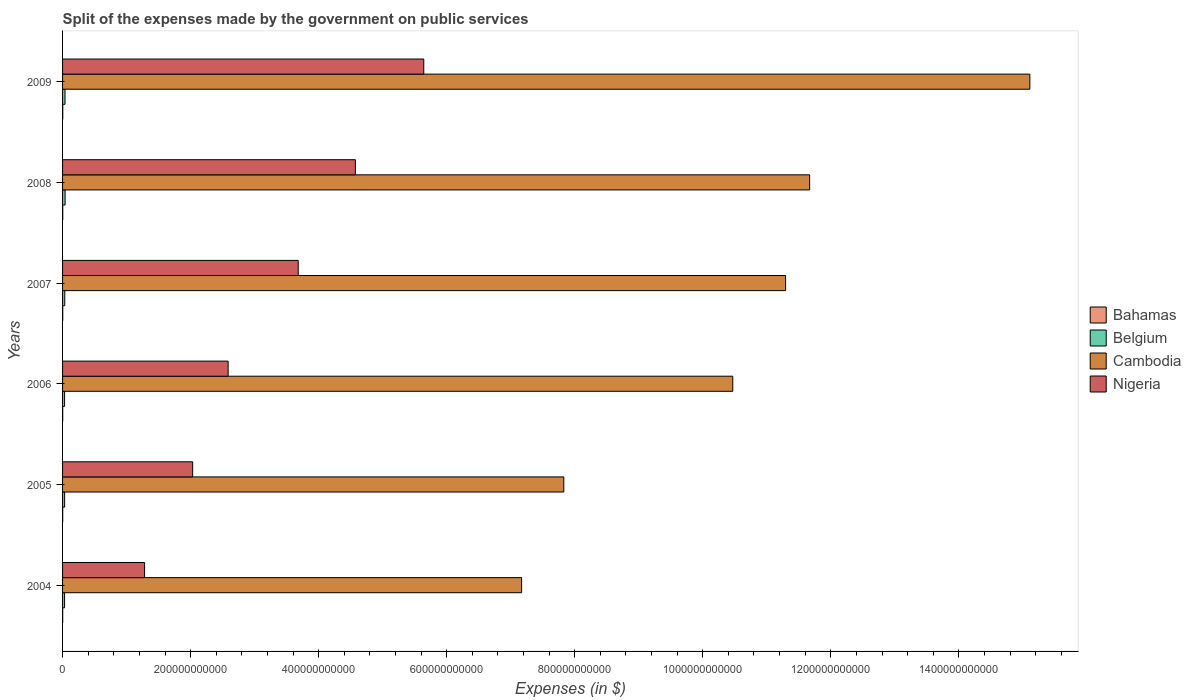Are the number of bars per tick equal to the number of legend labels?
Offer a terse response. Yes. Are the number of bars on each tick of the Y-axis equal?
Your response must be concise. Yes. What is the label of the 3rd group of bars from the top?
Give a very brief answer. 2007. In how many cases, is the number of bars for a given year not equal to the number of legend labels?
Offer a terse response. 0. What is the expenses made by the government on public services in Nigeria in 2008?
Your answer should be very brief. 4.57e+11. Across all years, what is the maximum expenses made by the government on public services in Cambodia?
Your response must be concise. 1.51e+12. Across all years, what is the minimum expenses made by the government on public services in Cambodia?
Your response must be concise. 7.17e+11. What is the total expenses made by the government on public services in Nigeria in the graph?
Keep it short and to the point. 1.98e+12. What is the difference between the expenses made by the government on public services in Bahamas in 2005 and that in 2006?
Your answer should be compact. -1.85e+07. What is the difference between the expenses made by the government on public services in Bahamas in 2009 and the expenses made by the government on public services in Cambodia in 2007?
Make the answer very short. -1.13e+12. What is the average expenses made by the government on public services in Cambodia per year?
Your answer should be compact. 1.06e+12. In the year 2008, what is the difference between the expenses made by the government on public services in Belgium and expenses made by the government on public services in Cambodia?
Your answer should be compact. -1.16e+12. What is the ratio of the expenses made by the government on public services in Cambodia in 2007 to that in 2008?
Keep it short and to the point. 0.97. Is the expenses made by the government on public services in Cambodia in 2004 less than that in 2005?
Provide a succinct answer. Yes. Is the difference between the expenses made by the government on public services in Belgium in 2006 and 2009 greater than the difference between the expenses made by the government on public services in Cambodia in 2006 and 2009?
Offer a terse response. Yes. What is the difference between the highest and the second highest expenses made by the government on public services in Cambodia?
Your answer should be very brief. 3.44e+11. What is the difference between the highest and the lowest expenses made by the government on public services in Nigeria?
Offer a terse response. 4.36e+11. Is the sum of the expenses made by the government on public services in Cambodia in 2005 and 2009 greater than the maximum expenses made by the government on public services in Nigeria across all years?
Give a very brief answer. Yes. Is it the case that in every year, the sum of the expenses made by the government on public services in Belgium and expenses made by the government on public services in Nigeria is greater than the sum of expenses made by the government on public services in Cambodia and expenses made by the government on public services in Bahamas?
Give a very brief answer. No. What does the 3rd bar from the top in 2007 represents?
Your answer should be very brief. Belgium. What does the 1st bar from the bottom in 2006 represents?
Offer a terse response. Bahamas. Is it the case that in every year, the sum of the expenses made by the government on public services in Belgium and expenses made by the government on public services in Nigeria is greater than the expenses made by the government on public services in Bahamas?
Your answer should be compact. Yes. Are all the bars in the graph horizontal?
Your response must be concise. Yes. What is the difference between two consecutive major ticks on the X-axis?
Give a very brief answer. 2.00e+11. Does the graph contain any zero values?
Make the answer very short. No. Does the graph contain grids?
Your answer should be compact. No. Where does the legend appear in the graph?
Your answer should be compact. Center right. How many legend labels are there?
Ensure brevity in your answer.  4. How are the legend labels stacked?
Give a very brief answer. Vertical. What is the title of the graph?
Offer a terse response. Split of the expenses made by the government on public services. What is the label or title of the X-axis?
Give a very brief answer. Expenses (in $). What is the Expenses (in $) of Bahamas in 2004?
Provide a succinct answer. 1.99e+08. What is the Expenses (in $) of Belgium in 2004?
Provide a short and direct response. 3.14e+09. What is the Expenses (in $) of Cambodia in 2004?
Make the answer very short. 7.17e+11. What is the Expenses (in $) in Nigeria in 2004?
Your answer should be compact. 1.28e+11. What is the Expenses (in $) in Bahamas in 2005?
Keep it short and to the point. 2.20e+08. What is the Expenses (in $) in Belgium in 2005?
Give a very brief answer. 3.21e+09. What is the Expenses (in $) of Cambodia in 2005?
Your response must be concise. 7.83e+11. What is the Expenses (in $) in Nigeria in 2005?
Provide a short and direct response. 2.03e+11. What is the Expenses (in $) in Bahamas in 2006?
Provide a succinct answer. 2.39e+08. What is the Expenses (in $) of Belgium in 2006?
Offer a terse response. 3.16e+09. What is the Expenses (in $) in Cambodia in 2006?
Ensure brevity in your answer.  1.05e+12. What is the Expenses (in $) of Nigeria in 2006?
Provide a succinct answer. 2.59e+11. What is the Expenses (in $) of Bahamas in 2007?
Offer a terse response. 2.64e+08. What is the Expenses (in $) in Belgium in 2007?
Your response must be concise. 3.44e+09. What is the Expenses (in $) in Cambodia in 2007?
Make the answer very short. 1.13e+12. What is the Expenses (in $) of Nigeria in 2007?
Offer a terse response. 3.68e+11. What is the Expenses (in $) in Bahamas in 2008?
Keep it short and to the point. 2.85e+08. What is the Expenses (in $) in Belgium in 2008?
Keep it short and to the point. 3.95e+09. What is the Expenses (in $) of Cambodia in 2008?
Your answer should be very brief. 1.17e+12. What is the Expenses (in $) in Nigeria in 2008?
Give a very brief answer. 4.57e+11. What is the Expenses (in $) of Bahamas in 2009?
Your answer should be compact. 3.19e+08. What is the Expenses (in $) of Belgium in 2009?
Your response must be concise. 3.79e+09. What is the Expenses (in $) in Cambodia in 2009?
Make the answer very short. 1.51e+12. What is the Expenses (in $) in Nigeria in 2009?
Your answer should be very brief. 5.64e+11. Across all years, what is the maximum Expenses (in $) in Bahamas?
Your response must be concise. 3.19e+08. Across all years, what is the maximum Expenses (in $) in Belgium?
Ensure brevity in your answer.  3.95e+09. Across all years, what is the maximum Expenses (in $) in Cambodia?
Provide a succinct answer. 1.51e+12. Across all years, what is the maximum Expenses (in $) in Nigeria?
Make the answer very short. 5.64e+11. Across all years, what is the minimum Expenses (in $) of Bahamas?
Your answer should be compact. 1.99e+08. Across all years, what is the minimum Expenses (in $) of Belgium?
Ensure brevity in your answer.  3.14e+09. Across all years, what is the minimum Expenses (in $) in Cambodia?
Give a very brief answer. 7.17e+11. Across all years, what is the minimum Expenses (in $) in Nigeria?
Provide a short and direct response. 1.28e+11. What is the total Expenses (in $) in Bahamas in the graph?
Offer a very short reply. 1.53e+09. What is the total Expenses (in $) in Belgium in the graph?
Offer a very short reply. 2.07e+1. What is the total Expenses (in $) in Cambodia in the graph?
Your answer should be compact. 6.35e+12. What is the total Expenses (in $) of Nigeria in the graph?
Provide a succinct answer. 1.98e+12. What is the difference between the Expenses (in $) of Bahamas in 2004 and that in 2005?
Ensure brevity in your answer.  -2.10e+07. What is the difference between the Expenses (in $) of Belgium in 2004 and that in 2005?
Provide a short and direct response. -7.35e+07. What is the difference between the Expenses (in $) of Cambodia in 2004 and that in 2005?
Ensure brevity in your answer.  -6.59e+1. What is the difference between the Expenses (in $) of Nigeria in 2004 and that in 2005?
Ensure brevity in your answer.  -7.51e+1. What is the difference between the Expenses (in $) of Bahamas in 2004 and that in 2006?
Your response must be concise. -3.95e+07. What is the difference between the Expenses (in $) of Belgium in 2004 and that in 2006?
Your response must be concise. -1.81e+07. What is the difference between the Expenses (in $) of Cambodia in 2004 and that in 2006?
Provide a succinct answer. -3.30e+11. What is the difference between the Expenses (in $) in Nigeria in 2004 and that in 2006?
Your answer should be very brief. -1.30e+11. What is the difference between the Expenses (in $) of Bahamas in 2004 and that in 2007?
Provide a succinct answer. -6.46e+07. What is the difference between the Expenses (in $) in Belgium in 2004 and that in 2007?
Your answer should be very brief. -2.98e+08. What is the difference between the Expenses (in $) in Cambodia in 2004 and that in 2007?
Offer a very short reply. -4.12e+11. What is the difference between the Expenses (in $) of Nigeria in 2004 and that in 2007?
Give a very brief answer. -2.40e+11. What is the difference between the Expenses (in $) in Bahamas in 2004 and that in 2008?
Provide a succinct answer. -8.55e+07. What is the difference between the Expenses (in $) in Belgium in 2004 and that in 2008?
Your answer should be very brief. -8.09e+08. What is the difference between the Expenses (in $) in Cambodia in 2004 and that in 2008?
Offer a very short reply. -4.50e+11. What is the difference between the Expenses (in $) of Nigeria in 2004 and that in 2008?
Your answer should be compact. -3.29e+11. What is the difference between the Expenses (in $) in Bahamas in 2004 and that in 2009?
Keep it short and to the point. -1.20e+08. What is the difference between the Expenses (in $) of Belgium in 2004 and that in 2009?
Make the answer very short. -6.52e+08. What is the difference between the Expenses (in $) of Cambodia in 2004 and that in 2009?
Your answer should be compact. -7.94e+11. What is the difference between the Expenses (in $) in Nigeria in 2004 and that in 2009?
Ensure brevity in your answer.  -4.36e+11. What is the difference between the Expenses (in $) of Bahamas in 2005 and that in 2006?
Make the answer very short. -1.85e+07. What is the difference between the Expenses (in $) in Belgium in 2005 and that in 2006?
Your answer should be very brief. 5.54e+07. What is the difference between the Expenses (in $) of Cambodia in 2005 and that in 2006?
Make the answer very short. -2.64e+11. What is the difference between the Expenses (in $) of Nigeria in 2005 and that in 2006?
Your response must be concise. -5.54e+1. What is the difference between the Expenses (in $) in Bahamas in 2005 and that in 2007?
Ensure brevity in your answer.  -4.36e+07. What is the difference between the Expenses (in $) in Belgium in 2005 and that in 2007?
Provide a short and direct response. -2.24e+08. What is the difference between the Expenses (in $) of Cambodia in 2005 and that in 2007?
Offer a terse response. -3.46e+11. What is the difference between the Expenses (in $) in Nigeria in 2005 and that in 2007?
Your response must be concise. -1.65e+11. What is the difference between the Expenses (in $) in Bahamas in 2005 and that in 2008?
Your answer should be very brief. -6.45e+07. What is the difference between the Expenses (in $) in Belgium in 2005 and that in 2008?
Give a very brief answer. -7.36e+08. What is the difference between the Expenses (in $) of Cambodia in 2005 and that in 2008?
Offer a terse response. -3.84e+11. What is the difference between the Expenses (in $) of Nigeria in 2005 and that in 2008?
Ensure brevity in your answer.  -2.54e+11. What is the difference between the Expenses (in $) of Bahamas in 2005 and that in 2009?
Keep it short and to the point. -9.90e+07. What is the difference between the Expenses (in $) in Belgium in 2005 and that in 2009?
Your response must be concise. -5.78e+08. What is the difference between the Expenses (in $) of Cambodia in 2005 and that in 2009?
Keep it short and to the point. -7.28e+11. What is the difference between the Expenses (in $) in Nigeria in 2005 and that in 2009?
Give a very brief answer. -3.61e+11. What is the difference between the Expenses (in $) in Bahamas in 2006 and that in 2007?
Make the answer very short. -2.51e+07. What is the difference between the Expenses (in $) of Belgium in 2006 and that in 2007?
Keep it short and to the point. -2.80e+08. What is the difference between the Expenses (in $) in Cambodia in 2006 and that in 2007?
Your answer should be compact. -8.25e+1. What is the difference between the Expenses (in $) of Nigeria in 2006 and that in 2007?
Ensure brevity in your answer.  -1.10e+11. What is the difference between the Expenses (in $) of Bahamas in 2006 and that in 2008?
Provide a short and direct response. -4.60e+07. What is the difference between the Expenses (in $) of Belgium in 2006 and that in 2008?
Offer a very short reply. -7.91e+08. What is the difference between the Expenses (in $) in Cambodia in 2006 and that in 2008?
Make the answer very short. -1.20e+11. What is the difference between the Expenses (in $) in Nigeria in 2006 and that in 2008?
Provide a succinct answer. -1.99e+11. What is the difference between the Expenses (in $) in Bahamas in 2006 and that in 2009?
Offer a terse response. -8.05e+07. What is the difference between the Expenses (in $) in Belgium in 2006 and that in 2009?
Offer a terse response. -6.34e+08. What is the difference between the Expenses (in $) of Cambodia in 2006 and that in 2009?
Your response must be concise. -4.64e+11. What is the difference between the Expenses (in $) in Nigeria in 2006 and that in 2009?
Ensure brevity in your answer.  -3.06e+11. What is the difference between the Expenses (in $) of Bahamas in 2007 and that in 2008?
Provide a short and direct response. -2.10e+07. What is the difference between the Expenses (in $) of Belgium in 2007 and that in 2008?
Provide a succinct answer. -5.12e+08. What is the difference between the Expenses (in $) in Cambodia in 2007 and that in 2008?
Make the answer very short. -3.75e+1. What is the difference between the Expenses (in $) in Nigeria in 2007 and that in 2008?
Keep it short and to the point. -8.93e+1. What is the difference between the Expenses (in $) of Bahamas in 2007 and that in 2009?
Your answer should be compact. -5.55e+07. What is the difference between the Expenses (in $) of Belgium in 2007 and that in 2009?
Offer a very short reply. -3.54e+08. What is the difference between the Expenses (in $) of Cambodia in 2007 and that in 2009?
Provide a short and direct response. -3.81e+11. What is the difference between the Expenses (in $) of Nigeria in 2007 and that in 2009?
Your answer should be compact. -1.96e+11. What is the difference between the Expenses (in $) of Bahamas in 2008 and that in 2009?
Ensure brevity in your answer.  -3.45e+07. What is the difference between the Expenses (in $) of Belgium in 2008 and that in 2009?
Keep it short and to the point. 1.58e+08. What is the difference between the Expenses (in $) in Cambodia in 2008 and that in 2009?
Offer a terse response. -3.44e+11. What is the difference between the Expenses (in $) of Nigeria in 2008 and that in 2009?
Offer a terse response. -1.07e+11. What is the difference between the Expenses (in $) of Bahamas in 2004 and the Expenses (in $) of Belgium in 2005?
Provide a succinct answer. -3.01e+09. What is the difference between the Expenses (in $) of Bahamas in 2004 and the Expenses (in $) of Cambodia in 2005?
Provide a short and direct response. -7.83e+11. What is the difference between the Expenses (in $) in Bahamas in 2004 and the Expenses (in $) in Nigeria in 2005?
Provide a succinct answer. -2.03e+11. What is the difference between the Expenses (in $) in Belgium in 2004 and the Expenses (in $) in Cambodia in 2005?
Offer a very short reply. -7.80e+11. What is the difference between the Expenses (in $) of Belgium in 2004 and the Expenses (in $) of Nigeria in 2005?
Your answer should be compact. -2.00e+11. What is the difference between the Expenses (in $) in Cambodia in 2004 and the Expenses (in $) in Nigeria in 2005?
Offer a terse response. 5.14e+11. What is the difference between the Expenses (in $) in Bahamas in 2004 and the Expenses (in $) in Belgium in 2006?
Your answer should be compact. -2.96e+09. What is the difference between the Expenses (in $) in Bahamas in 2004 and the Expenses (in $) in Cambodia in 2006?
Provide a short and direct response. -1.05e+12. What is the difference between the Expenses (in $) in Bahamas in 2004 and the Expenses (in $) in Nigeria in 2006?
Offer a very short reply. -2.58e+11. What is the difference between the Expenses (in $) of Belgium in 2004 and the Expenses (in $) of Cambodia in 2006?
Provide a succinct answer. -1.04e+12. What is the difference between the Expenses (in $) in Belgium in 2004 and the Expenses (in $) in Nigeria in 2006?
Give a very brief answer. -2.55e+11. What is the difference between the Expenses (in $) in Cambodia in 2004 and the Expenses (in $) in Nigeria in 2006?
Your response must be concise. 4.58e+11. What is the difference between the Expenses (in $) in Bahamas in 2004 and the Expenses (in $) in Belgium in 2007?
Keep it short and to the point. -3.24e+09. What is the difference between the Expenses (in $) of Bahamas in 2004 and the Expenses (in $) of Cambodia in 2007?
Your answer should be compact. -1.13e+12. What is the difference between the Expenses (in $) of Bahamas in 2004 and the Expenses (in $) of Nigeria in 2007?
Your response must be concise. -3.68e+11. What is the difference between the Expenses (in $) of Belgium in 2004 and the Expenses (in $) of Cambodia in 2007?
Offer a terse response. -1.13e+12. What is the difference between the Expenses (in $) in Belgium in 2004 and the Expenses (in $) in Nigeria in 2007?
Keep it short and to the point. -3.65e+11. What is the difference between the Expenses (in $) in Cambodia in 2004 and the Expenses (in $) in Nigeria in 2007?
Make the answer very short. 3.49e+11. What is the difference between the Expenses (in $) of Bahamas in 2004 and the Expenses (in $) of Belgium in 2008?
Offer a terse response. -3.75e+09. What is the difference between the Expenses (in $) of Bahamas in 2004 and the Expenses (in $) of Cambodia in 2008?
Your response must be concise. -1.17e+12. What is the difference between the Expenses (in $) in Bahamas in 2004 and the Expenses (in $) in Nigeria in 2008?
Offer a very short reply. -4.57e+11. What is the difference between the Expenses (in $) in Belgium in 2004 and the Expenses (in $) in Cambodia in 2008?
Provide a short and direct response. -1.16e+12. What is the difference between the Expenses (in $) of Belgium in 2004 and the Expenses (in $) of Nigeria in 2008?
Your response must be concise. -4.54e+11. What is the difference between the Expenses (in $) in Cambodia in 2004 and the Expenses (in $) in Nigeria in 2008?
Your response must be concise. 2.60e+11. What is the difference between the Expenses (in $) in Bahamas in 2004 and the Expenses (in $) in Belgium in 2009?
Your answer should be compact. -3.59e+09. What is the difference between the Expenses (in $) in Bahamas in 2004 and the Expenses (in $) in Cambodia in 2009?
Provide a succinct answer. -1.51e+12. What is the difference between the Expenses (in $) of Bahamas in 2004 and the Expenses (in $) of Nigeria in 2009?
Your response must be concise. -5.64e+11. What is the difference between the Expenses (in $) in Belgium in 2004 and the Expenses (in $) in Cambodia in 2009?
Offer a very short reply. -1.51e+12. What is the difference between the Expenses (in $) of Belgium in 2004 and the Expenses (in $) of Nigeria in 2009?
Give a very brief answer. -5.61e+11. What is the difference between the Expenses (in $) of Cambodia in 2004 and the Expenses (in $) of Nigeria in 2009?
Give a very brief answer. 1.53e+11. What is the difference between the Expenses (in $) in Bahamas in 2005 and the Expenses (in $) in Belgium in 2006?
Offer a terse response. -2.94e+09. What is the difference between the Expenses (in $) in Bahamas in 2005 and the Expenses (in $) in Cambodia in 2006?
Give a very brief answer. -1.05e+12. What is the difference between the Expenses (in $) in Bahamas in 2005 and the Expenses (in $) in Nigeria in 2006?
Provide a short and direct response. -2.58e+11. What is the difference between the Expenses (in $) in Belgium in 2005 and the Expenses (in $) in Cambodia in 2006?
Offer a very short reply. -1.04e+12. What is the difference between the Expenses (in $) in Belgium in 2005 and the Expenses (in $) in Nigeria in 2006?
Offer a very short reply. -2.55e+11. What is the difference between the Expenses (in $) of Cambodia in 2005 and the Expenses (in $) of Nigeria in 2006?
Ensure brevity in your answer.  5.24e+11. What is the difference between the Expenses (in $) in Bahamas in 2005 and the Expenses (in $) in Belgium in 2007?
Your response must be concise. -3.22e+09. What is the difference between the Expenses (in $) in Bahamas in 2005 and the Expenses (in $) in Cambodia in 2007?
Your answer should be compact. -1.13e+12. What is the difference between the Expenses (in $) of Bahamas in 2005 and the Expenses (in $) of Nigeria in 2007?
Your answer should be compact. -3.68e+11. What is the difference between the Expenses (in $) in Belgium in 2005 and the Expenses (in $) in Cambodia in 2007?
Your response must be concise. -1.13e+12. What is the difference between the Expenses (in $) of Belgium in 2005 and the Expenses (in $) of Nigeria in 2007?
Your response must be concise. -3.65e+11. What is the difference between the Expenses (in $) of Cambodia in 2005 and the Expenses (in $) of Nigeria in 2007?
Offer a very short reply. 4.15e+11. What is the difference between the Expenses (in $) of Bahamas in 2005 and the Expenses (in $) of Belgium in 2008?
Your response must be concise. -3.73e+09. What is the difference between the Expenses (in $) in Bahamas in 2005 and the Expenses (in $) in Cambodia in 2008?
Your answer should be very brief. -1.17e+12. What is the difference between the Expenses (in $) of Bahamas in 2005 and the Expenses (in $) of Nigeria in 2008?
Give a very brief answer. -4.57e+11. What is the difference between the Expenses (in $) in Belgium in 2005 and the Expenses (in $) in Cambodia in 2008?
Keep it short and to the point. -1.16e+12. What is the difference between the Expenses (in $) of Belgium in 2005 and the Expenses (in $) of Nigeria in 2008?
Keep it short and to the point. -4.54e+11. What is the difference between the Expenses (in $) in Cambodia in 2005 and the Expenses (in $) in Nigeria in 2008?
Your response must be concise. 3.26e+11. What is the difference between the Expenses (in $) of Bahamas in 2005 and the Expenses (in $) of Belgium in 2009?
Your response must be concise. -3.57e+09. What is the difference between the Expenses (in $) of Bahamas in 2005 and the Expenses (in $) of Cambodia in 2009?
Ensure brevity in your answer.  -1.51e+12. What is the difference between the Expenses (in $) of Bahamas in 2005 and the Expenses (in $) of Nigeria in 2009?
Keep it short and to the point. -5.64e+11. What is the difference between the Expenses (in $) in Belgium in 2005 and the Expenses (in $) in Cambodia in 2009?
Provide a short and direct response. -1.51e+12. What is the difference between the Expenses (in $) in Belgium in 2005 and the Expenses (in $) in Nigeria in 2009?
Your response must be concise. -5.61e+11. What is the difference between the Expenses (in $) of Cambodia in 2005 and the Expenses (in $) of Nigeria in 2009?
Keep it short and to the point. 2.19e+11. What is the difference between the Expenses (in $) in Bahamas in 2006 and the Expenses (in $) in Belgium in 2007?
Offer a very short reply. -3.20e+09. What is the difference between the Expenses (in $) of Bahamas in 2006 and the Expenses (in $) of Cambodia in 2007?
Offer a very short reply. -1.13e+12. What is the difference between the Expenses (in $) of Bahamas in 2006 and the Expenses (in $) of Nigeria in 2007?
Your response must be concise. -3.68e+11. What is the difference between the Expenses (in $) in Belgium in 2006 and the Expenses (in $) in Cambodia in 2007?
Provide a succinct answer. -1.13e+12. What is the difference between the Expenses (in $) in Belgium in 2006 and the Expenses (in $) in Nigeria in 2007?
Provide a succinct answer. -3.65e+11. What is the difference between the Expenses (in $) of Cambodia in 2006 and the Expenses (in $) of Nigeria in 2007?
Provide a succinct answer. 6.79e+11. What is the difference between the Expenses (in $) in Bahamas in 2006 and the Expenses (in $) in Belgium in 2008?
Make the answer very short. -3.71e+09. What is the difference between the Expenses (in $) of Bahamas in 2006 and the Expenses (in $) of Cambodia in 2008?
Your answer should be compact. -1.17e+12. What is the difference between the Expenses (in $) of Bahamas in 2006 and the Expenses (in $) of Nigeria in 2008?
Offer a very short reply. -4.57e+11. What is the difference between the Expenses (in $) in Belgium in 2006 and the Expenses (in $) in Cambodia in 2008?
Your answer should be compact. -1.16e+12. What is the difference between the Expenses (in $) of Belgium in 2006 and the Expenses (in $) of Nigeria in 2008?
Give a very brief answer. -4.54e+11. What is the difference between the Expenses (in $) of Cambodia in 2006 and the Expenses (in $) of Nigeria in 2008?
Make the answer very short. 5.89e+11. What is the difference between the Expenses (in $) of Bahamas in 2006 and the Expenses (in $) of Belgium in 2009?
Your answer should be compact. -3.55e+09. What is the difference between the Expenses (in $) in Bahamas in 2006 and the Expenses (in $) in Cambodia in 2009?
Your answer should be compact. -1.51e+12. What is the difference between the Expenses (in $) in Bahamas in 2006 and the Expenses (in $) in Nigeria in 2009?
Your answer should be very brief. -5.64e+11. What is the difference between the Expenses (in $) of Belgium in 2006 and the Expenses (in $) of Cambodia in 2009?
Provide a short and direct response. -1.51e+12. What is the difference between the Expenses (in $) of Belgium in 2006 and the Expenses (in $) of Nigeria in 2009?
Provide a succinct answer. -5.61e+11. What is the difference between the Expenses (in $) in Cambodia in 2006 and the Expenses (in $) in Nigeria in 2009?
Keep it short and to the point. 4.83e+11. What is the difference between the Expenses (in $) in Bahamas in 2007 and the Expenses (in $) in Belgium in 2008?
Make the answer very short. -3.69e+09. What is the difference between the Expenses (in $) of Bahamas in 2007 and the Expenses (in $) of Cambodia in 2008?
Keep it short and to the point. -1.17e+12. What is the difference between the Expenses (in $) of Bahamas in 2007 and the Expenses (in $) of Nigeria in 2008?
Make the answer very short. -4.57e+11. What is the difference between the Expenses (in $) in Belgium in 2007 and the Expenses (in $) in Cambodia in 2008?
Your response must be concise. -1.16e+12. What is the difference between the Expenses (in $) of Belgium in 2007 and the Expenses (in $) of Nigeria in 2008?
Provide a short and direct response. -4.54e+11. What is the difference between the Expenses (in $) in Cambodia in 2007 and the Expenses (in $) in Nigeria in 2008?
Your answer should be very brief. 6.72e+11. What is the difference between the Expenses (in $) in Bahamas in 2007 and the Expenses (in $) in Belgium in 2009?
Your response must be concise. -3.53e+09. What is the difference between the Expenses (in $) of Bahamas in 2007 and the Expenses (in $) of Cambodia in 2009?
Your answer should be compact. -1.51e+12. What is the difference between the Expenses (in $) in Bahamas in 2007 and the Expenses (in $) in Nigeria in 2009?
Make the answer very short. -5.64e+11. What is the difference between the Expenses (in $) in Belgium in 2007 and the Expenses (in $) in Cambodia in 2009?
Give a very brief answer. -1.51e+12. What is the difference between the Expenses (in $) of Belgium in 2007 and the Expenses (in $) of Nigeria in 2009?
Give a very brief answer. -5.61e+11. What is the difference between the Expenses (in $) in Cambodia in 2007 and the Expenses (in $) in Nigeria in 2009?
Provide a succinct answer. 5.65e+11. What is the difference between the Expenses (in $) of Bahamas in 2008 and the Expenses (in $) of Belgium in 2009?
Your answer should be very brief. -3.51e+09. What is the difference between the Expenses (in $) of Bahamas in 2008 and the Expenses (in $) of Cambodia in 2009?
Your response must be concise. -1.51e+12. What is the difference between the Expenses (in $) of Bahamas in 2008 and the Expenses (in $) of Nigeria in 2009?
Your answer should be compact. -5.64e+11. What is the difference between the Expenses (in $) of Belgium in 2008 and the Expenses (in $) of Cambodia in 2009?
Make the answer very short. -1.51e+12. What is the difference between the Expenses (in $) of Belgium in 2008 and the Expenses (in $) of Nigeria in 2009?
Offer a terse response. -5.60e+11. What is the difference between the Expenses (in $) in Cambodia in 2008 and the Expenses (in $) in Nigeria in 2009?
Offer a very short reply. 6.03e+11. What is the average Expenses (in $) in Bahamas per year?
Offer a terse response. 2.54e+08. What is the average Expenses (in $) of Belgium per year?
Provide a succinct answer. 3.45e+09. What is the average Expenses (in $) in Cambodia per year?
Your answer should be very brief. 1.06e+12. What is the average Expenses (in $) of Nigeria per year?
Keep it short and to the point. 3.30e+11. In the year 2004, what is the difference between the Expenses (in $) in Bahamas and Expenses (in $) in Belgium?
Your answer should be compact. -2.94e+09. In the year 2004, what is the difference between the Expenses (in $) of Bahamas and Expenses (in $) of Cambodia?
Keep it short and to the point. -7.17e+11. In the year 2004, what is the difference between the Expenses (in $) in Bahamas and Expenses (in $) in Nigeria?
Provide a short and direct response. -1.28e+11. In the year 2004, what is the difference between the Expenses (in $) in Belgium and Expenses (in $) in Cambodia?
Make the answer very short. -7.14e+11. In the year 2004, what is the difference between the Expenses (in $) of Belgium and Expenses (in $) of Nigeria?
Your answer should be compact. -1.25e+11. In the year 2004, what is the difference between the Expenses (in $) in Cambodia and Expenses (in $) in Nigeria?
Make the answer very short. 5.89e+11. In the year 2005, what is the difference between the Expenses (in $) in Bahamas and Expenses (in $) in Belgium?
Give a very brief answer. -2.99e+09. In the year 2005, what is the difference between the Expenses (in $) of Bahamas and Expenses (in $) of Cambodia?
Keep it short and to the point. -7.83e+11. In the year 2005, what is the difference between the Expenses (in $) in Bahamas and Expenses (in $) in Nigeria?
Ensure brevity in your answer.  -2.03e+11. In the year 2005, what is the difference between the Expenses (in $) of Belgium and Expenses (in $) of Cambodia?
Your response must be concise. -7.80e+11. In the year 2005, what is the difference between the Expenses (in $) of Belgium and Expenses (in $) of Nigeria?
Make the answer very short. -2.00e+11. In the year 2005, what is the difference between the Expenses (in $) in Cambodia and Expenses (in $) in Nigeria?
Keep it short and to the point. 5.80e+11. In the year 2006, what is the difference between the Expenses (in $) in Bahamas and Expenses (in $) in Belgium?
Make the answer very short. -2.92e+09. In the year 2006, what is the difference between the Expenses (in $) of Bahamas and Expenses (in $) of Cambodia?
Make the answer very short. -1.05e+12. In the year 2006, what is the difference between the Expenses (in $) of Bahamas and Expenses (in $) of Nigeria?
Keep it short and to the point. -2.58e+11. In the year 2006, what is the difference between the Expenses (in $) of Belgium and Expenses (in $) of Cambodia?
Your response must be concise. -1.04e+12. In the year 2006, what is the difference between the Expenses (in $) of Belgium and Expenses (in $) of Nigeria?
Make the answer very short. -2.55e+11. In the year 2006, what is the difference between the Expenses (in $) of Cambodia and Expenses (in $) of Nigeria?
Keep it short and to the point. 7.88e+11. In the year 2007, what is the difference between the Expenses (in $) of Bahamas and Expenses (in $) of Belgium?
Ensure brevity in your answer.  -3.17e+09. In the year 2007, what is the difference between the Expenses (in $) in Bahamas and Expenses (in $) in Cambodia?
Provide a short and direct response. -1.13e+12. In the year 2007, what is the difference between the Expenses (in $) in Bahamas and Expenses (in $) in Nigeria?
Keep it short and to the point. -3.68e+11. In the year 2007, what is the difference between the Expenses (in $) in Belgium and Expenses (in $) in Cambodia?
Make the answer very short. -1.13e+12. In the year 2007, what is the difference between the Expenses (in $) of Belgium and Expenses (in $) of Nigeria?
Make the answer very short. -3.65e+11. In the year 2007, what is the difference between the Expenses (in $) of Cambodia and Expenses (in $) of Nigeria?
Give a very brief answer. 7.61e+11. In the year 2008, what is the difference between the Expenses (in $) in Bahamas and Expenses (in $) in Belgium?
Give a very brief answer. -3.66e+09. In the year 2008, what is the difference between the Expenses (in $) in Bahamas and Expenses (in $) in Cambodia?
Your answer should be very brief. -1.17e+12. In the year 2008, what is the difference between the Expenses (in $) of Bahamas and Expenses (in $) of Nigeria?
Your answer should be compact. -4.57e+11. In the year 2008, what is the difference between the Expenses (in $) in Belgium and Expenses (in $) in Cambodia?
Your answer should be very brief. -1.16e+12. In the year 2008, what is the difference between the Expenses (in $) of Belgium and Expenses (in $) of Nigeria?
Provide a short and direct response. -4.53e+11. In the year 2008, what is the difference between the Expenses (in $) in Cambodia and Expenses (in $) in Nigeria?
Ensure brevity in your answer.  7.10e+11. In the year 2009, what is the difference between the Expenses (in $) in Bahamas and Expenses (in $) in Belgium?
Your answer should be compact. -3.47e+09. In the year 2009, what is the difference between the Expenses (in $) in Bahamas and Expenses (in $) in Cambodia?
Keep it short and to the point. -1.51e+12. In the year 2009, what is the difference between the Expenses (in $) of Bahamas and Expenses (in $) of Nigeria?
Make the answer very short. -5.64e+11. In the year 2009, what is the difference between the Expenses (in $) of Belgium and Expenses (in $) of Cambodia?
Your response must be concise. -1.51e+12. In the year 2009, what is the difference between the Expenses (in $) of Belgium and Expenses (in $) of Nigeria?
Keep it short and to the point. -5.60e+11. In the year 2009, what is the difference between the Expenses (in $) in Cambodia and Expenses (in $) in Nigeria?
Offer a terse response. 9.47e+11. What is the ratio of the Expenses (in $) of Bahamas in 2004 to that in 2005?
Your answer should be very brief. 0.9. What is the ratio of the Expenses (in $) of Belgium in 2004 to that in 2005?
Your response must be concise. 0.98. What is the ratio of the Expenses (in $) in Cambodia in 2004 to that in 2005?
Keep it short and to the point. 0.92. What is the ratio of the Expenses (in $) of Nigeria in 2004 to that in 2005?
Keep it short and to the point. 0.63. What is the ratio of the Expenses (in $) of Bahamas in 2004 to that in 2006?
Keep it short and to the point. 0.83. What is the ratio of the Expenses (in $) in Cambodia in 2004 to that in 2006?
Offer a very short reply. 0.69. What is the ratio of the Expenses (in $) of Nigeria in 2004 to that in 2006?
Your response must be concise. 0.5. What is the ratio of the Expenses (in $) in Bahamas in 2004 to that in 2007?
Ensure brevity in your answer.  0.76. What is the ratio of the Expenses (in $) in Belgium in 2004 to that in 2007?
Provide a succinct answer. 0.91. What is the ratio of the Expenses (in $) of Cambodia in 2004 to that in 2007?
Your answer should be compact. 0.63. What is the ratio of the Expenses (in $) of Nigeria in 2004 to that in 2007?
Offer a very short reply. 0.35. What is the ratio of the Expenses (in $) in Bahamas in 2004 to that in 2008?
Keep it short and to the point. 0.7. What is the ratio of the Expenses (in $) in Belgium in 2004 to that in 2008?
Your answer should be compact. 0.8. What is the ratio of the Expenses (in $) of Cambodia in 2004 to that in 2008?
Offer a terse response. 0.61. What is the ratio of the Expenses (in $) of Nigeria in 2004 to that in 2008?
Your response must be concise. 0.28. What is the ratio of the Expenses (in $) in Bahamas in 2004 to that in 2009?
Your answer should be compact. 0.62. What is the ratio of the Expenses (in $) in Belgium in 2004 to that in 2009?
Keep it short and to the point. 0.83. What is the ratio of the Expenses (in $) of Cambodia in 2004 to that in 2009?
Offer a terse response. 0.47. What is the ratio of the Expenses (in $) in Nigeria in 2004 to that in 2009?
Offer a terse response. 0.23. What is the ratio of the Expenses (in $) in Bahamas in 2005 to that in 2006?
Your answer should be very brief. 0.92. What is the ratio of the Expenses (in $) of Belgium in 2005 to that in 2006?
Your response must be concise. 1.02. What is the ratio of the Expenses (in $) in Cambodia in 2005 to that in 2006?
Give a very brief answer. 0.75. What is the ratio of the Expenses (in $) of Nigeria in 2005 to that in 2006?
Your response must be concise. 0.79. What is the ratio of the Expenses (in $) of Bahamas in 2005 to that in 2007?
Your response must be concise. 0.83. What is the ratio of the Expenses (in $) of Belgium in 2005 to that in 2007?
Give a very brief answer. 0.93. What is the ratio of the Expenses (in $) in Cambodia in 2005 to that in 2007?
Keep it short and to the point. 0.69. What is the ratio of the Expenses (in $) of Nigeria in 2005 to that in 2007?
Your answer should be compact. 0.55. What is the ratio of the Expenses (in $) in Bahamas in 2005 to that in 2008?
Make the answer very short. 0.77. What is the ratio of the Expenses (in $) of Belgium in 2005 to that in 2008?
Give a very brief answer. 0.81. What is the ratio of the Expenses (in $) of Cambodia in 2005 to that in 2008?
Give a very brief answer. 0.67. What is the ratio of the Expenses (in $) of Nigeria in 2005 to that in 2008?
Provide a short and direct response. 0.44. What is the ratio of the Expenses (in $) in Bahamas in 2005 to that in 2009?
Ensure brevity in your answer.  0.69. What is the ratio of the Expenses (in $) of Belgium in 2005 to that in 2009?
Offer a terse response. 0.85. What is the ratio of the Expenses (in $) in Cambodia in 2005 to that in 2009?
Offer a very short reply. 0.52. What is the ratio of the Expenses (in $) of Nigeria in 2005 to that in 2009?
Your response must be concise. 0.36. What is the ratio of the Expenses (in $) in Bahamas in 2006 to that in 2007?
Your response must be concise. 0.91. What is the ratio of the Expenses (in $) of Belgium in 2006 to that in 2007?
Ensure brevity in your answer.  0.92. What is the ratio of the Expenses (in $) of Cambodia in 2006 to that in 2007?
Make the answer very short. 0.93. What is the ratio of the Expenses (in $) of Nigeria in 2006 to that in 2007?
Your answer should be very brief. 0.7. What is the ratio of the Expenses (in $) of Bahamas in 2006 to that in 2008?
Keep it short and to the point. 0.84. What is the ratio of the Expenses (in $) of Belgium in 2006 to that in 2008?
Offer a terse response. 0.8. What is the ratio of the Expenses (in $) in Cambodia in 2006 to that in 2008?
Your answer should be compact. 0.9. What is the ratio of the Expenses (in $) of Nigeria in 2006 to that in 2008?
Offer a very short reply. 0.57. What is the ratio of the Expenses (in $) of Bahamas in 2006 to that in 2009?
Ensure brevity in your answer.  0.75. What is the ratio of the Expenses (in $) in Belgium in 2006 to that in 2009?
Keep it short and to the point. 0.83. What is the ratio of the Expenses (in $) in Cambodia in 2006 to that in 2009?
Offer a terse response. 0.69. What is the ratio of the Expenses (in $) of Nigeria in 2006 to that in 2009?
Provide a short and direct response. 0.46. What is the ratio of the Expenses (in $) in Bahamas in 2007 to that in 2008?
Offer a very short reply. 0.93. What is the ratio of the Expenses (in $) of Belgium in 2007 to that in 2008?
Offer a terse response. 0.87. What is the ratio of the Expenses (in $) of Cambodia in 2007 to that in 2008?
Your answer should be compact. 0.97. What is the ratio of the Expenses (in $) of Nigeria in 2007 to that in 2008?
Ensure brevity in your answer.  0.8. What is the ratio of the Expenses (in $) of Bahamas in 2007 to that in 2009?
Ensure brevity in your answer.  0.83. What is the ratio of the Expenses (in $) in Belgium in 2007 to that in 2009?
Your response must be concise. 0.91. What is the ratio of the Expenses (in $) in Cambodia in 2007 to that in 2009?
Your response must be concise. 0.75. What is the ratio of the Expenses (in $) of Nigeria in 2007 to that in 2009?
Make the answer very short. 0.65. What is the ratio of the Expenses (in $) of Bahamas in 2008 to that in 2009?
Keep it short and to the point. 0.89. What is the ratio of the Expenses (in $) in Belgium in 2008 to that in 2009?
Make the answer very short. 1.04. What is the ratio of the Expenses (in $) in Cambodia in 2008 to that in 2009?
Provide a short and direct response. 0.77. What is the ratio of the Expenses (in $) of Nigeria in 2008 to that in 2009?
Offer a terse response. 0.81. What is the difference between the highest and the second highest Expenses (in $) of Bahamas?
Your answer should be very brief. 3.45e+07. What is the difference between the highest and the second highest Expenses (in $) of Belgium?
Provide a short and direct response. 1.58e+08. What is the difference between the highest and the second highest Expenses (in $) in Cambodia?
Offer a very short reply. 3.44e+11. What is the difference between the highest and the second highest Expenses (in $) in Nigeria?
Offer a very short reply. 1.07e+11. What is the difference between the highest and the lowest Expenses (in $) of Bahamas?
Make the answer very short. 1.20e+08. What is the difference between the highest and the lowest Expenses (in $) of Belgium?
Ensure brevity in your answer.  8.09e+08. What is the difference between the highest and the lowest Expenses (in $) of Cambodia?
Offer a terse response. 7.94e+11. What is the difference between the highest and the lowest Expenses (in $) in Nigeria?
Ensure brevity in your answer.  4.36e+11. 